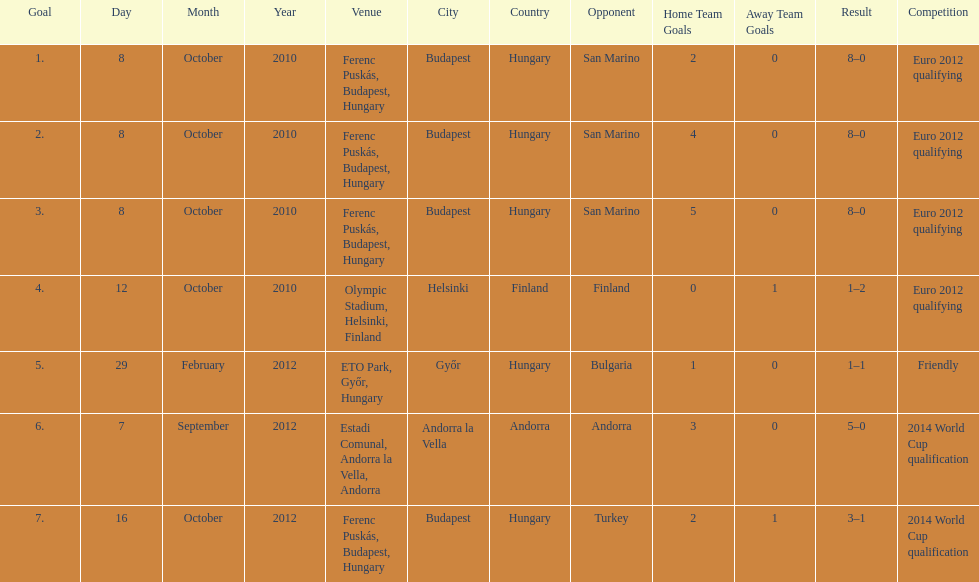Szalai scored only one more international goal against all other countries put together than he did against what one country? San Marino. 